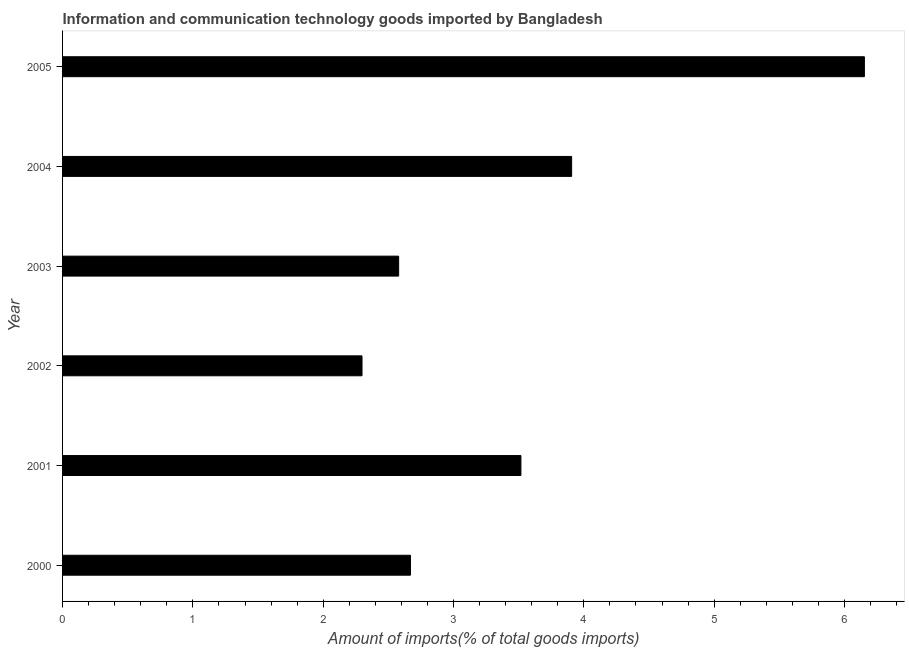Does the graph contain any zero values?
Give a very brief answer. No. Does the graph contain grids?
Offer a terse response. No. What is the title of the graph?
Provide a succinct answer. Information and communication technology goods imported by Bangladesh. What is the label or title of the X-axis?
Give a very brief answer. Amount of imports(% of total goods imports). What is the amount of ict goods imports in 2000?
Offer a very short reply. 2.67. Across all years, what is the maximum amount of ict goods imports?
Your answer should be compact. 6.15. Across all years, what is the minimum amount of ict goods imports?
Give a very brief answer. 2.3. What is the sum of the amount of ict goods imports?
Give a very brief answer. 21.12. What is the difference between the amount of ict goods imports in 2000 and 2002?
Your answer should be very brief. 0.37. What is the average amount of ict goods imports per year?
Your answer should be compact. 3.52. What is the median amount of ict goods imports?
Your answer should be compact. 3.09. Do a majority of the years between 2003 and 2004 (inclusive) have amount of ict goods imports greater than 6 %?
Your response must be concise. No. What is the ratio of the amount of ict goods imports in 2004 to that in 2005?
Offer a terse response. 0.64. What is the difference between the highest and the second highest amount of ict goods imports?
Your response must be concise. 2.25. What is the difference between the highest and the lowest amount of ict goods imports?
Offer a very short reply. 3.86. In how many years, is the amount of ict goods imports greater than the average amount of ict goods imports taken over all years?
Make the answer very short. 2. What is the difference between two consecutive major ticks on the X-axis?
Give a very brief answer. 1. What is the Amount of imports(% of total goods imports) in 2000?
Your answer should be compact. 2.67. What is the Amount of imports(% of total goods imports) of 2001?
Give a very brief answer. 3.52. What is the Amount of imports(% of total goods imports) in 2002?
Provide a short and direct response. 2.3. What is the Amount of imports(% of total goods imports) in 2003?
Offer a terse response. 2.58. What is the Amount of imports(% of total goods imports) of 2004?
Make the answer very short. 3.91. What is the Amount of imports(% of total goods imports) in 2005?
Provide a succinct answer. 6.15. What is the difference between the Amount of imports(% of total goods imports) in 2000 and 2001?
Give a very brief answer. -0.85. What is the difference between the Amount of imports(% of total goods imports) in 2000 and 2002?
Keep it short and to the point. 0.37. What is the difference between the Amount of imports(% of total goods imports) in 2000 and 2003?
Ensure brevity in your answer.  0.09. What is the difference between the Amount of imports(% of total goods imports) in 2000 and 2004?
Provide a short and direct response. -1.24. What is the difference between the Amount of imports(% of total goods imports) in 2000 and 2005?
Keep it short and to the point. -3.48. What is the difference between the Amount of imports(% of total goods imports) in 2001 and 2002?
Make the answer very short. 1.22. What is the difference between the Amount of imports(% of total goods imports) in 2001 and 2003?
Offer a terse response. 0.94. What is the difference between the Amount of imports(% of total goods imports) in 2001 and 2004?
Your response must be concise. -0.39. What is the difference between the Amount of imports(% of total goods imports) in 2001 and 2005?
Offer a terse response. -2.64. What is the difference between the Amount of imports(% of total goods imports) in 2002 and 2003?
Make the answer very short. -0.28. What is the difference between the Amount of imports(% of total goods imports) in 2002 and 2004?
Give a very brief answer. -1.61. What is the difference between the Amount of imports(% of total goods imports) in 2002 and 2005?
Provide a succinct answer. -3.86. What is the difference between the Amount of imports(% of total goods imports) in 2003 and 2004?
Offer a very short reply. -1.33. What is the difference between the Amount of imports(% of total goods imports) in 2003 and 2005?
Provide a short and direct response. -3.57. What is the difference between the Amount of imports(% of total goods imports) in 2004 and 2005?
Give a very brief answer. -2.25. What is the ratio of the Amount of imports(% of total goods imports) in 2000 to that in 2001?
Keep it short and to the point. 0.76. What is the ratio of the Amount of imports(% of total goods imports) in 2000 to that in 2002?
Keep it short and to the point. 1.16. What is the ratio of the Amount of imports(% of total goods imports) in 2000 to that in 2003?
Offer a very short reply. 1.03. What is the ratio of the Amount of imports(% of total goods imports) in 2000 to that in 2004?
Offer a very short reply. 0.68. What is the ratio of the Amount of imports(% of total goods imports) in 2000 to that in 2005?
Offer a terse response. 0.43. What is the ratio of the Amount of imports(% of total goods imports) in 2001 to that in 2002?
Offer a terse response. 1.53. What is the ratio of the Amount of imports(% of total goods imports) in 2001 to that in 2003?
Provide a short and direct response. 1.36. What is the ratio of the Amount of imports(% of total goods imports) in 2001 to that in 2004?
Provide a succinct answer. 0.9. What is the ratio of the Amount of imports(% of total goods imports) in 2001 to that in 2005?
Provide a succinct answer. 0.57. What is the ratio of the Amount of imports(% of total goods imports) in 2002 to that in 2003?
Give a very brief answer. 0.89. What is the ratio of the Amount of imports(% of total goods imports) in 2002 to that in 2004?
Make the answer very short. 0.59. What is the ratio of the Amount of imports(% of total goods imports) in 2002 to that in 2005?
Keep it short and to the point. 0.37. What is the ratio of the Amount of imports(% of total goods imports) in 2003 to that in 2004?
Provide a succinct answer. 0.66. What is the ratio of the Amount of imports(% of total goods imports) in 2003 to that in 2005?
Provide a succinct answer. 0.42. What is the ratio of the Amount of imports(% of total goods imports) in 2004 to that in 2005?
Offer a terse response. 0.64. 